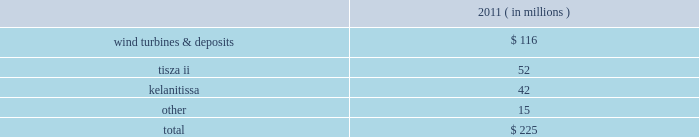The aes corporation notes to consolidated financial statements 2014 ( continued ) december 31 , 2011 , 2010 , and 2009 20 .
Impairment expense asset impairment asset impairment expense for the year ended december 31 , 2011 consisted of : ( in millions ) .
Wind turbines & deposits 2014during the third quarter of 2011 , the company evaluated the future use of certain wind turbines held in storage pending their installation .
Due to reduced wind turbine market pricing and advances in turbine technology , the company determined it was more likely than not that the turbines would be sold significantly before the end of their previously estimated useful lives .
In addition , the company has concluded that more likely than not non-refundable deposits it had made in prior years to a turbine manufacturer for the purchase of wind turbines are not recoverable .
The company determined it was more likely than not that it would not proceed with the purchase of turbines due to the availability of more advanced and lower cost turbines in the market .
These developments were more likely than not as of september 30 , 2011 and as a result were considered impairment indicators and the company determined that an impairment had occurred as of september 30 , 2011 as the aggregate carrying amount of $ 161 million of these assets was not recoverable and was reduced to their estimated fair value of $ 45 million determined under the market approach .
This resulted in asset impairment expense of $ 116 million .
Wind generation is reported in the corporate and other segment .
In january 2012 , the company forfeited the deposits for which a full impairment charge was recognized in the third quarter of 2011 , and there is no obligation for further payments under the related turbine supply agreement .
Additionally , the company sold some of the turbines held in storage during the fourth quarter of 2011 and is continuing to evaluate the future use of the turbines held in storage .
The company determined it is more likely than not that they will be sold , however they are not being actively marketed for sale at this time as the company is reconsidering the potential use of the turbines in light of recent development activity at one of its advance stage development projects .
It is reasonably possible that the turbines could incur further loss in value due to changing market conditions and advances in technology .
Tisza ii 2014during the fourth quarter of 2011 , tisza ii , a 900 mw gas and oil-fired generation plant in hungary entered into annual negotiations with its offtaker .
As a result of these negotiations , as well as the further deterioration of the economic environment in hungary , the company determined that an indicator of impairment existed at december 31 , 2011 .
Thus , the company performed an asset impairment test and determined that based on the undiscounted cash flow analysis , the carrying amount of tisza ii asset group was not recoverable .
The fair value of the asset group was then determined using a discounted cash flow analysis .
The carrying value of the tisza ii asset group of $ 94 million exceeded the fair value of $ 42 million resulting in the recognition of asset impairment expense of $ 52 million during the three months ended december 31 , 2011 .
Tisza ii is reported in the europe generation reportable segment .
Kelanitissa 2014in 2011 , the company recognized asset impairment expense of $ 42 million for the long-lived assets of kelanitissa , our diesel-fired generation plant in sri lanka .
We have continued to evaluate the recoverability of our long-lived assets at kelanitissa as a result of both the existing government regulation which .
During 2011 , what percentage of the wind turbines & deposits were written down? 
Computations: (116 / 161)
Answer: 0.7205. 